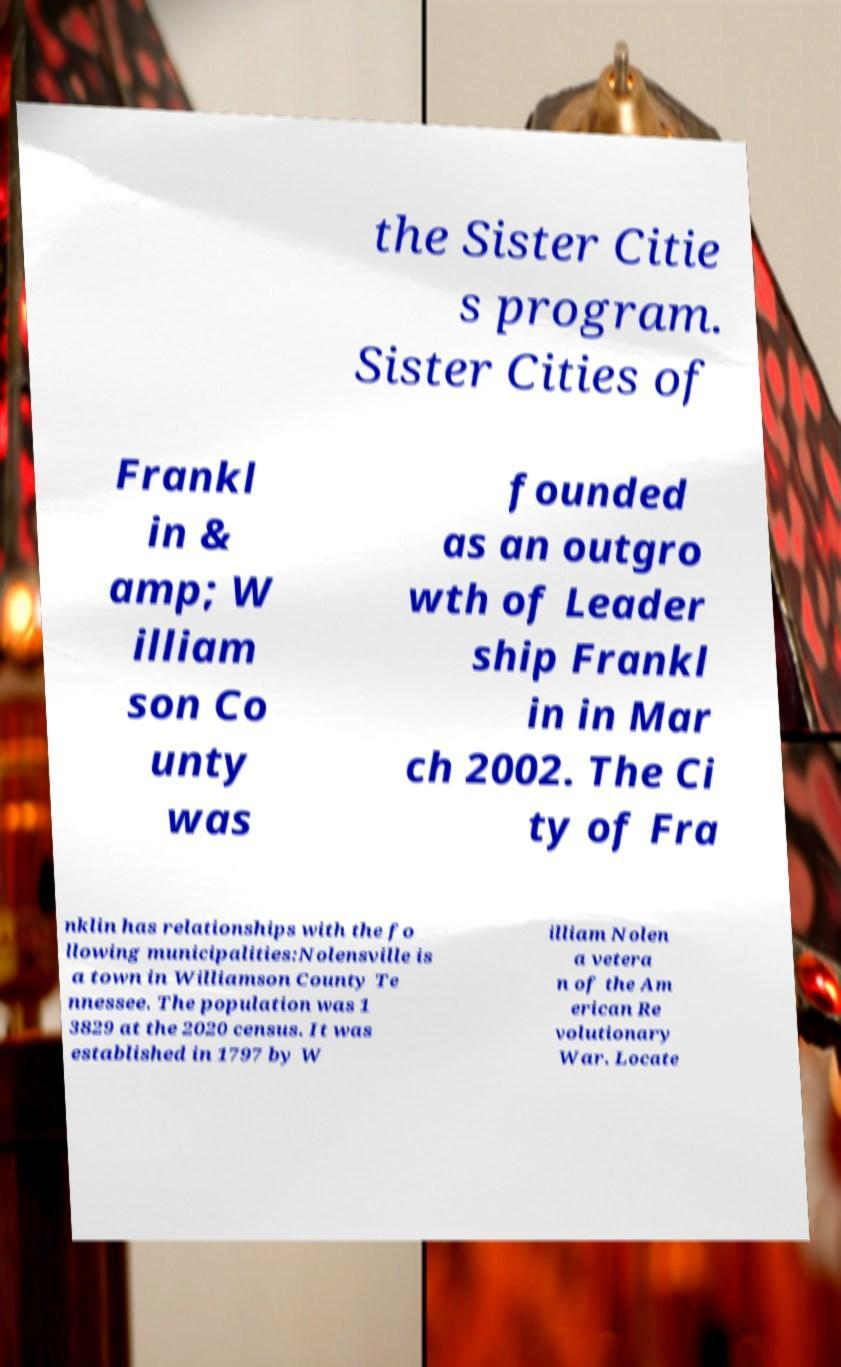Please read and relay the text visible in this image. What does it say? the Sister Citie s program. Sister Cities of Frankl in & amp; W illiam son Co unty was founded as an outgro wth of Leader ship Frankl in in Mar ch 2002. The Ci ty of Fra nklin has relationships with the fo llowing municipalities:Nolensville is a town in Williamson County Te nnessee. The population was 1 3829 at the 2020 census. It was established in 1797 by W illiam Nolen a vetera n of the Am erican Re volutionary War. Locate 